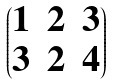<formula> <loc_0><loc_0><loc_500><loc_500>\begin{pmatrix} 1 & 2 & 3 \\ 3 & 2 & 4 \end{pmatrix}</formula> 